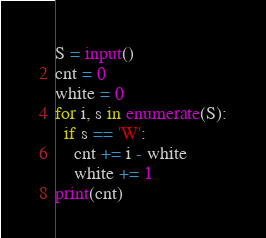Convert code to text. <code><loc_0><loc_0><loc_500><loc_500><_Python_>S = input()
cnt = 0
white = 0
for i, s in enumerate(S):
  if s == 'W':
    cnt += i - white
    white += 1
print(cnt)</code> 